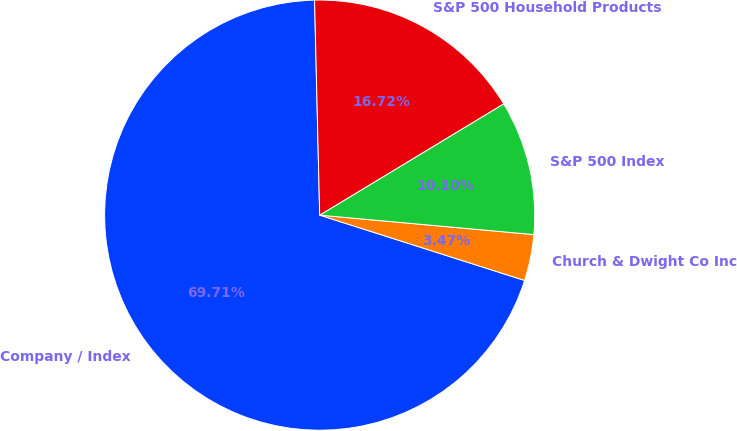<chart> <loc_0><loc_0><loc_500><loc_500><pie_chart><fcel>Company / Index<fcel>Church & Dwight Co Inc<fcel>S&P 500 Index<fcel>S&P 500 Household Products<nl><fcel>69.71%<fcel>3.47%<fcel>10.1%<fcel>16.72%<nl></chart> 